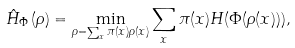Convert formula to latex. <formula><loc_0><loc_0><loc_500><loc_500>\hat { H } _ { \Phi } \left ( \rho \right ) = \min _ { \rho = \sum _ { x } \pi ( x ) \rho ( x ) } \sum _ { x } \pi ( x ) H ( \Phi ( \rho ( x ) ) ) ,</formula> 